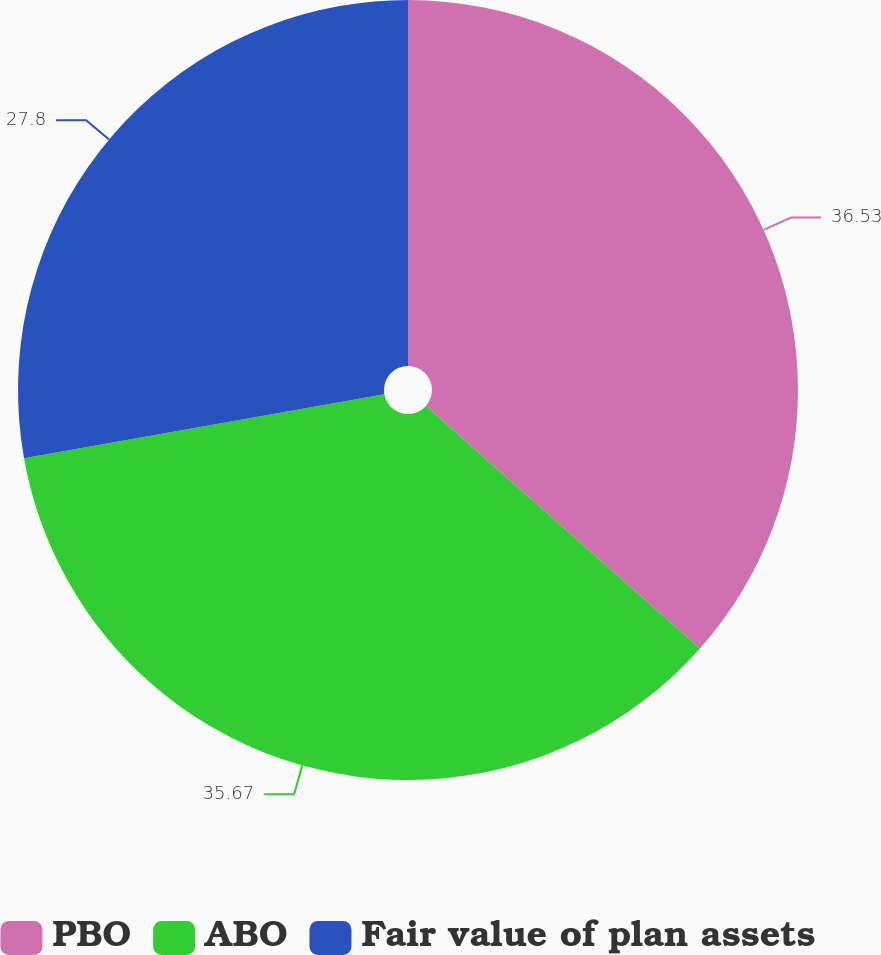Convert chart. <chart><loc_0><loc_0><loc_500><loc_500><pie_chart><fcel>PBO<fcel>ABO<fcel>Fair value of plan assets<nl><fcel>36.54%<fcel>35.67%<fcel>27.8%<nl></chart> 